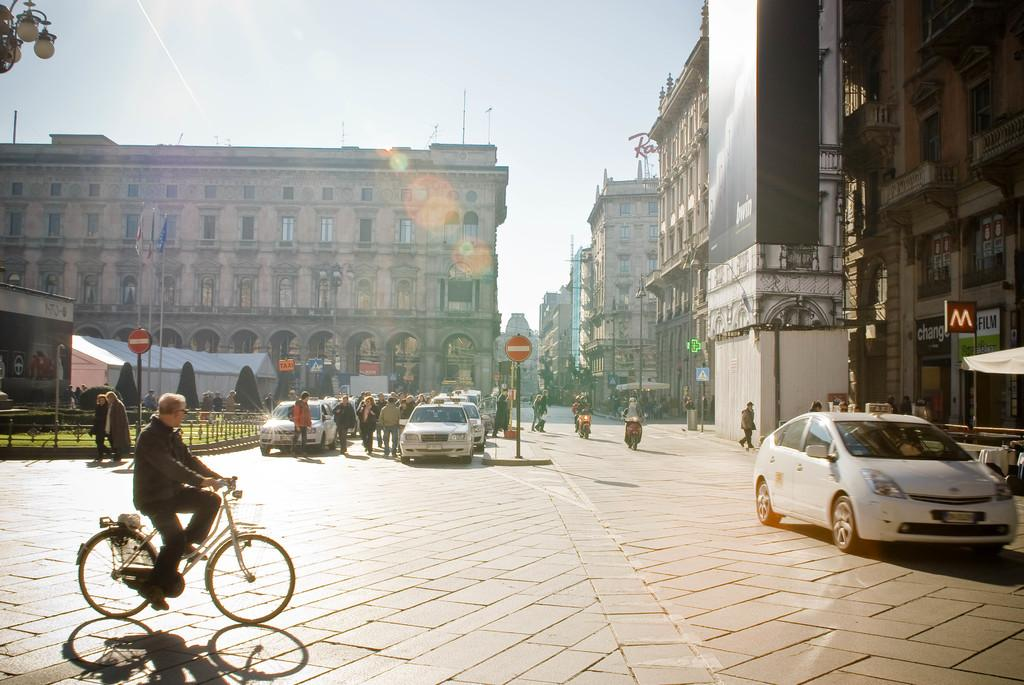What is the man doing in the image? The man is riding a bicycle in the street. What other vehicles can be seen in the image? There is a car in the image. What is the name board used for in the image? The name board is used to display a name or sign in the image. What type of structures are visible in the image? There are buildings in the image. What type of vegetation is present in the image? There is a tree in the image. What part of the natural environment is visible in the image? The sky is visible in the image. What temporary shelter is present in the image? There is a tent in the image. What source of light can be seen in the image? There is a light in the image. How many people are present in the street in the image? There is a group of persons in the street. How many ladybugs are crawling on the bicycle in the image? There are no ladybugs present in the image; it only features a man riding a bicycle, a car, a name board, buildings, a tree, the sky, a tent, a light, and a group of persons. 